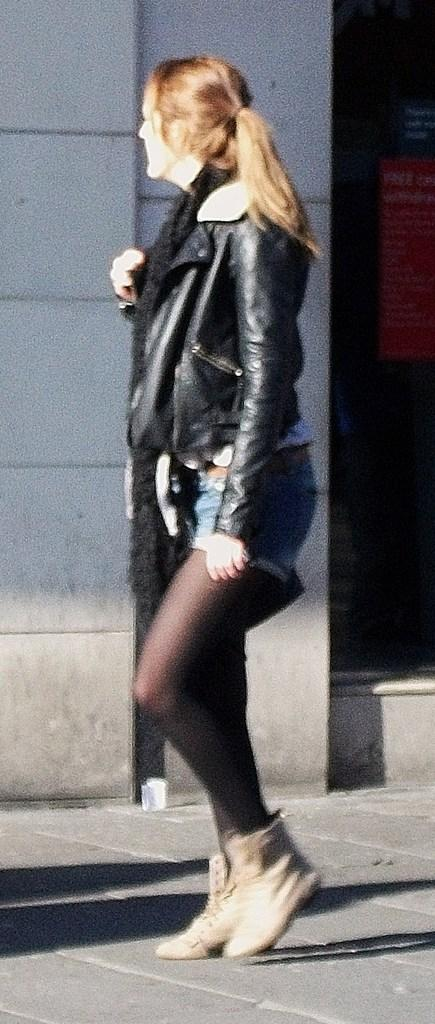Who is the main subject in the image? There is a woman in the image. What is the woman wearing? The woman is wearing a black jacket and boots. What is the woman doing in the image? The woman is walking on the road. What can be seen in the background of the image? There is a wall and posts in the background of the image. How many mice are sitting on the woman's head in the image? There are no mice present in the image, so it is not possible to answer that question. 